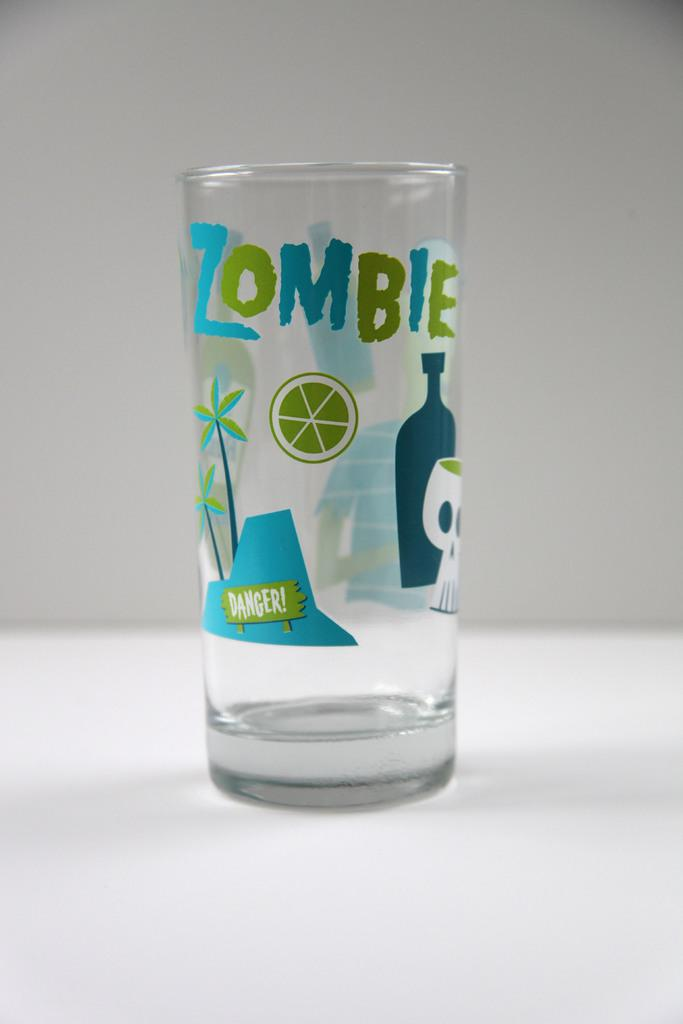<image>
Write a terse but informative summary of the picture. A glass cup with drawings on it and the word Zombie on the glass 